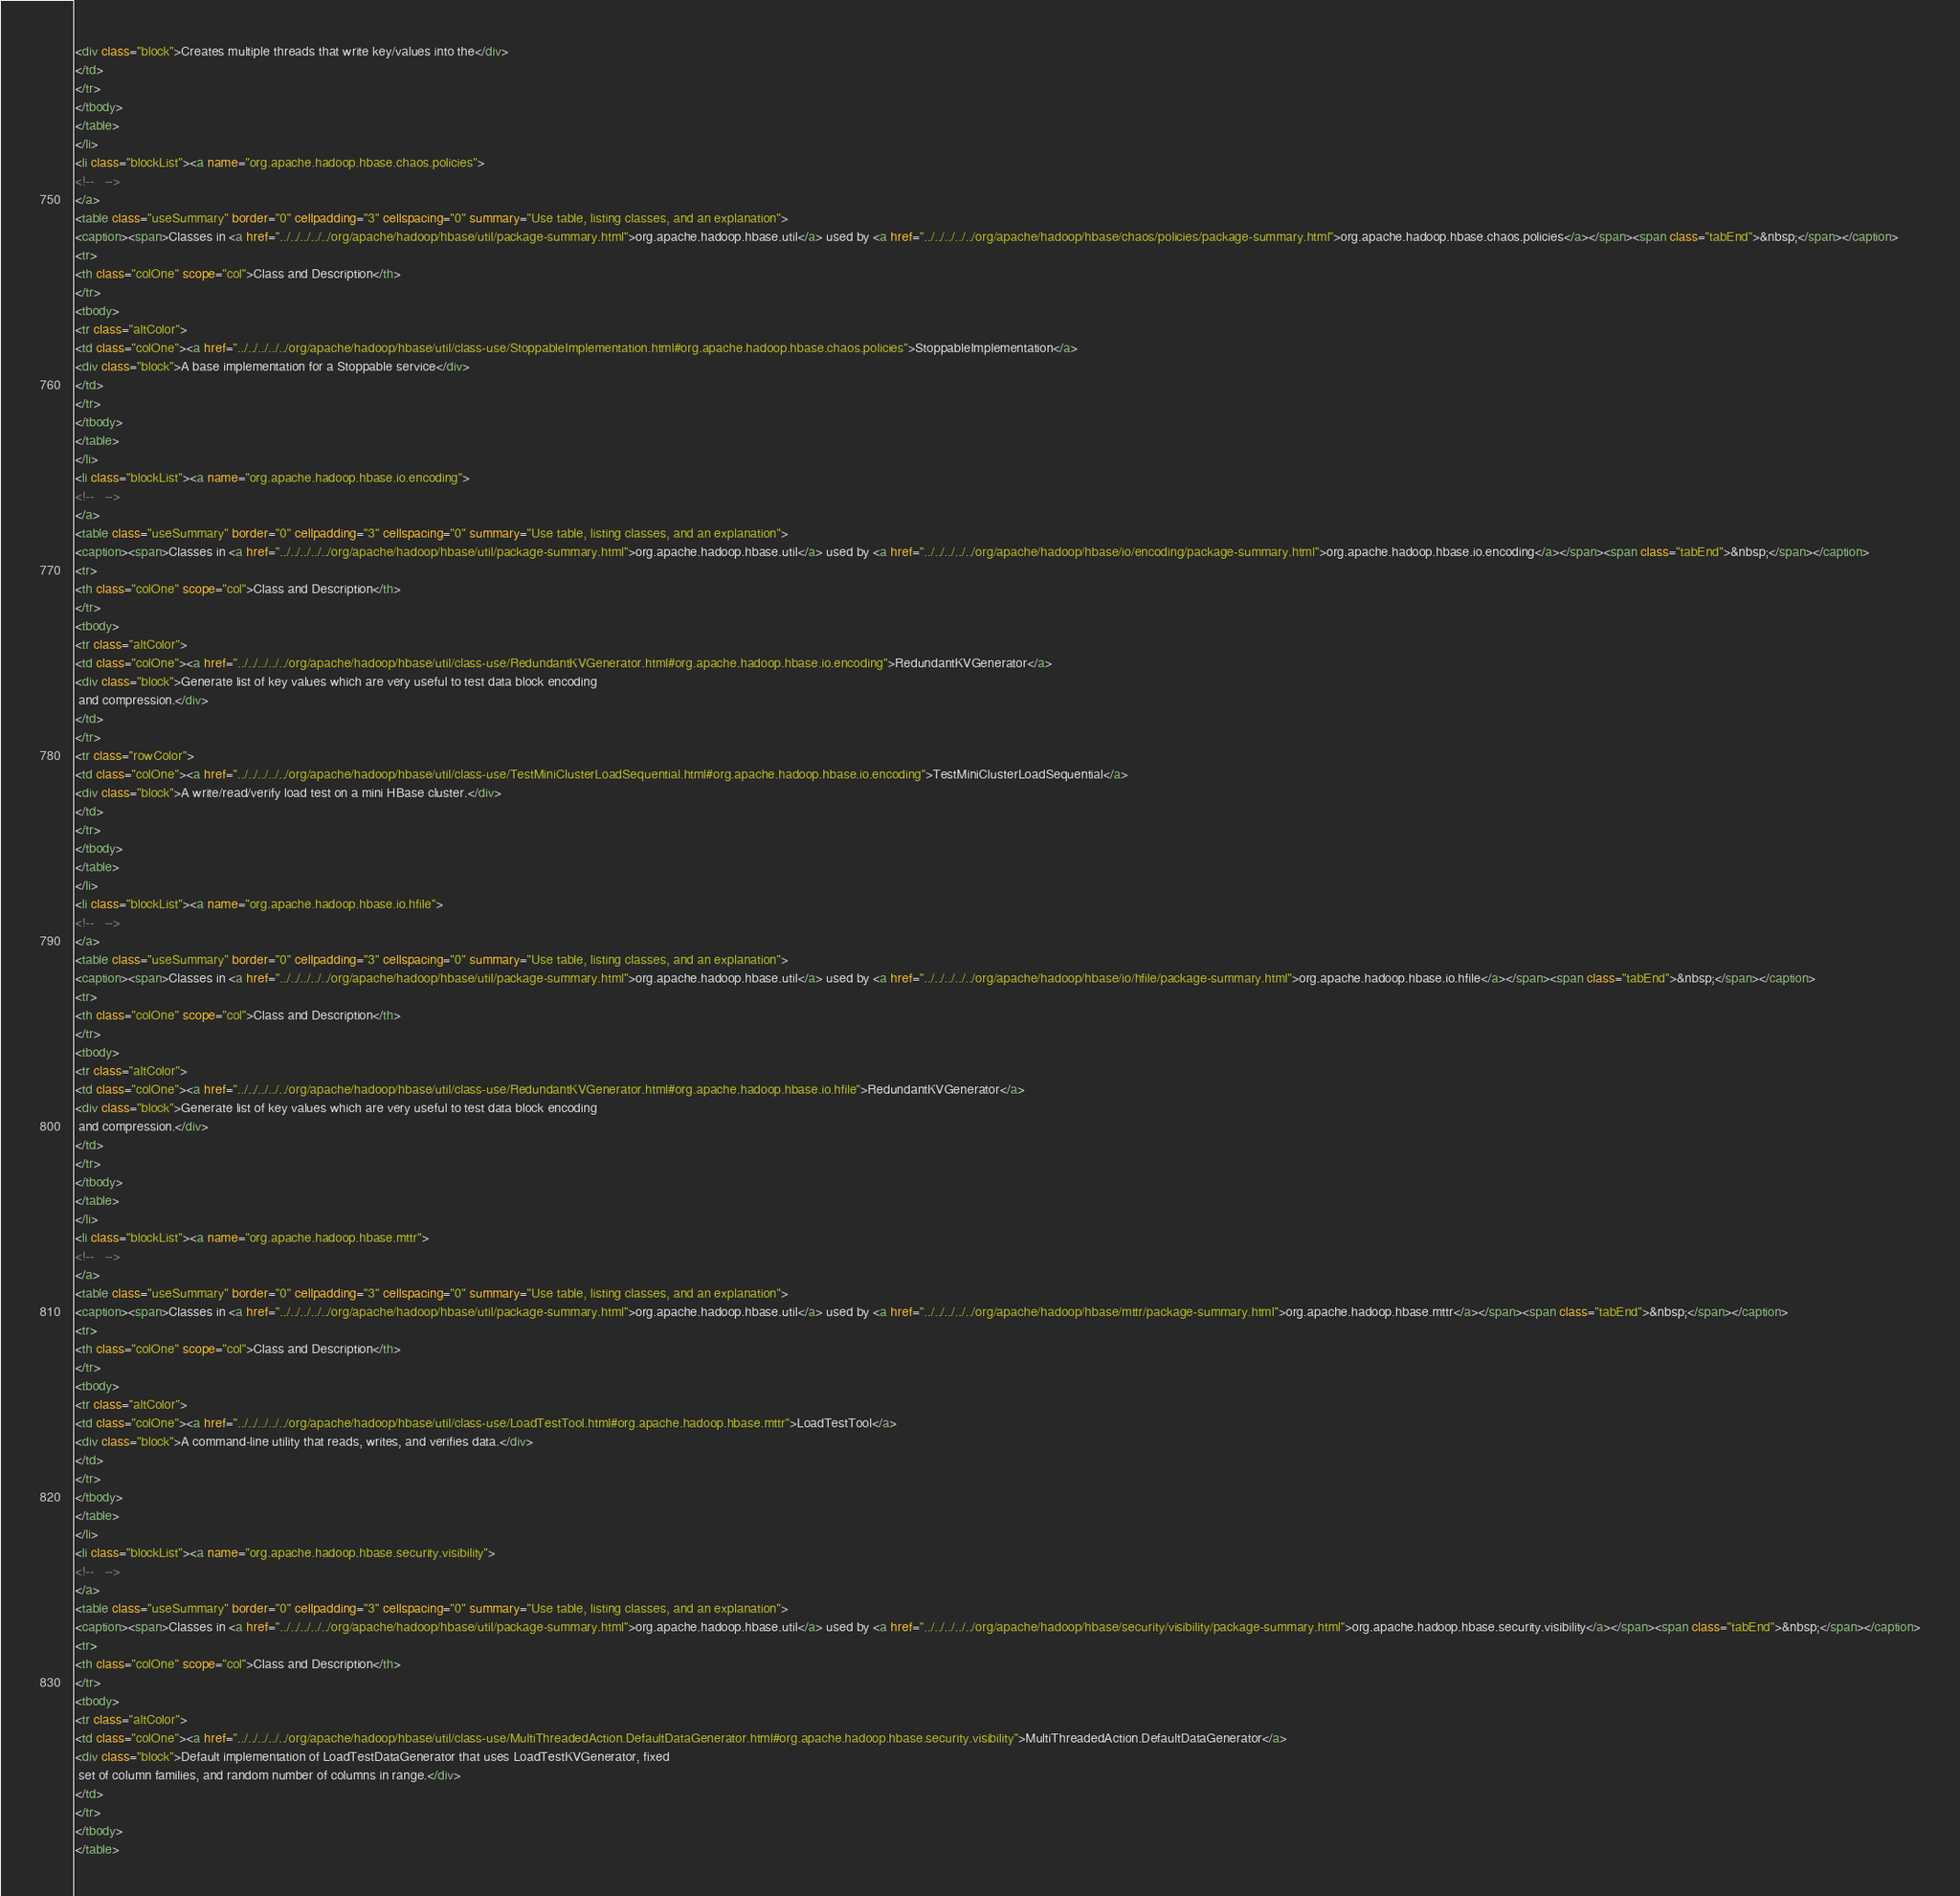Convert code to text. <code><loc_0><loc_0><loc_500><loc_500><_HTML_><div class="block">Creates multiple threads that write key/values into the</div>
</td>
</tr>
</tbody>
</table>
</li>
<li class="blockList"><a name="org.apache.hadoop.hbase.chaos.policies">
<!--   -->
</a>
<table class="useSummary" border="0" cellpadding="3" cellspacing="0" summary="Use table, listing classes, and an explanation">
<caption><span>Classes in <a href="../../../../../org/apache/hadoop/hbase/util/package-summary.html">org.apache.hadoop.hbase.util</a> used by <a href="../../../../../org/apache/hadoop/hbase/chaos/policies/package-summary.html">org.apache.hadoop.hbase.chaos.policies</a></span><span class="tabEnd">&nbsp;</span></caption>
<tr>
<th class="colOne" scope="col">Class and Description</th>
</tr>
<tbody>
<tr class="altColor">
<td class="colOne"><a href="../../../../../org/apache/hadoop/hbase/util/class-use/StoppableImplementation.html#org.apache.hadoop.hbase.chaos.policies">StoppableImplementation</a>
<div class="block">A base implementation for a Stoppable service</div>
</td>
</tr>
</tbody>
</table>
</li>
<li class="blockList"><a name="org.apache.hadoop.hbase.io.encoding">
<!--   -->
</a>
<table class="useSummary" border="0" cellpadding="3" cellspacing="0" summary="Use table, listing classes, and an explanation">
<caption><span>Classes in <a href="../../../../../org/apache/hadoop/hbase/util/package-summary.html">org.apache.hadoop.hbase.util</a> used by <a href="../../../../../org/apache/hadoop/hbase/io/encoding/package-summary.html">org.apache.hadoop.hbase.io.encoding</a></span><span class="tabEnd">&nbsp;</span></caption>
<tr>
<th class="colOne" scope="col">Class and Description</th>
</tr>
<tbody>
<tr class="altColor">
<td class="colOne"><a href="../../../../../org/apache/hadoop/hbase/util/class-use/RedundantKVGenerator.html#org.apache.hadoop.hbase.io.encoding">RedundantKVGenerator</a>
<div class="block">Generate list of key values which are very useful to test data block encoding
 and compression.</div>
</td>
</tr>
<tr class="rowColor">
<td class="colOne"><a href="../../../../../org/apache/hadoop/hbase/util/class-use/TestMiniClusterLoadSequential.html#org.apache.hadoop.hbase.io.encoding">TestMiniClusterLoadSequential</a>
<div class="block">A write/read/verify load test on a mini HBase cluster.</div>
</td>
</tr>
</tbody>
</table>
</li>
<li class="blockList"><a name="org.apache.hadoop.hbase.io.hfile">
<!--   -->
</a>
<table class="useSummary" border="0" cellpadding="3" cellspacing="0" summary="Use table, listing classes, and an explanation">
<caption><span>Classes in <a href="../../../../../org/apache/hadoop/hbase/util/package-summary.html">org.apache.hadoop.hbase.util</a> used by <a href="../../../../../org/apache/hadoop/hbase/io/hfile/package-summary.html">org.apache.hadoop.hbase.io.hfile</a></span><span class="tabEnd">&nbsp;</span></caption>
<tr>
<th class="colOne" scope="col">Class and Description</th>
</tr>
<tbody>
<tr class="altColor">
<td class="colOne"><a href="../../../../../org/apache/hadoop/hbase/util/class-use/RedundantKVGenerator.html#org.apache.hadoop.hbase.io.hfile">RedundantKVGenerator</a>
<div class="block">Generate list of key values which are very useful to test data block encoding
 and compression.</div>
</td>
</tr>
</tbody>
</table>
</li>
<li class="blockList"><a name="org.apache.hadoop.hbase.mttr">
<!--   -->
</a>
<table class="useSummary" border="0" cellpadding="3" cellspacing="0" summary="Use table, listing classes, and an explanation">
<caption><span>Classes in <a href="../../../../../org/apache/hadoop/hbase/util/package-summary.html">org.apache.hadoop.hbase.util</a> used by <a href="../../../../../org/apache/hadoop/hbase/mttr/package-summary.html">org.apache.hadoop.hbase.mttr</a></span><span class="tabEnd">&nbsp;</span></caption>
<tr>
<th class="colOne" scope="col">Class and Description</th>
</tr>
<tbody>
<tr class="altColor">
<td class="colOne"><a href="../../../../../org/apache/hadoop/hbase/util/class-use/LoadTestTool.html#org.apache.hadoop.hbase.mttr">LoadTestTool</a>
<div class="block">A command-line utility that reads, writes, and verifies data.</div>
</td>
</tr>
</tbody>
</table>
</li>
<li class="blockList"><a name="org.apache.hadoop.hbase.security.visibility">
<!--   -->
</a>
<table class="useSummary" border="0" cellpadding="3" cellspacing="0" summary="Use table, listing classes, and an explanation">
<caption><span>Classes in <a href="../../../../../org/apache/hadoop/hbase/util/package-summary.html">org.apache.hadoop.hbase.util</a> used by <a href="../../../../../org/apache/hadoop/hbase/security/visibility/package-summary.html">org.apache.hadoop.hbase.security.visibility</a></span><span class="tabEnd">&nbsp;</span></caption>
<tr>
<th class="colOne" scope="col">Class and Description</th>
</tr>
<tbody>
<tr class="altColor">
<td class="colOne"><a href="../../../../../org/apache/hadoop/hbase/util/class-use/MultiThreadedAction.DefaultDataGenerator.html#org.apache.hadoop.hbase.security.visibility">MultiThreadedAction.DefaultDataGenerator</a>
<div class="block">Default implementation of LoadTestDataGenerator that uses LoadTestKVGenerator, fixed
 set of column families, and random number of columns in range.</div>
</td>
</tr>
</tbody>
</table></code> 